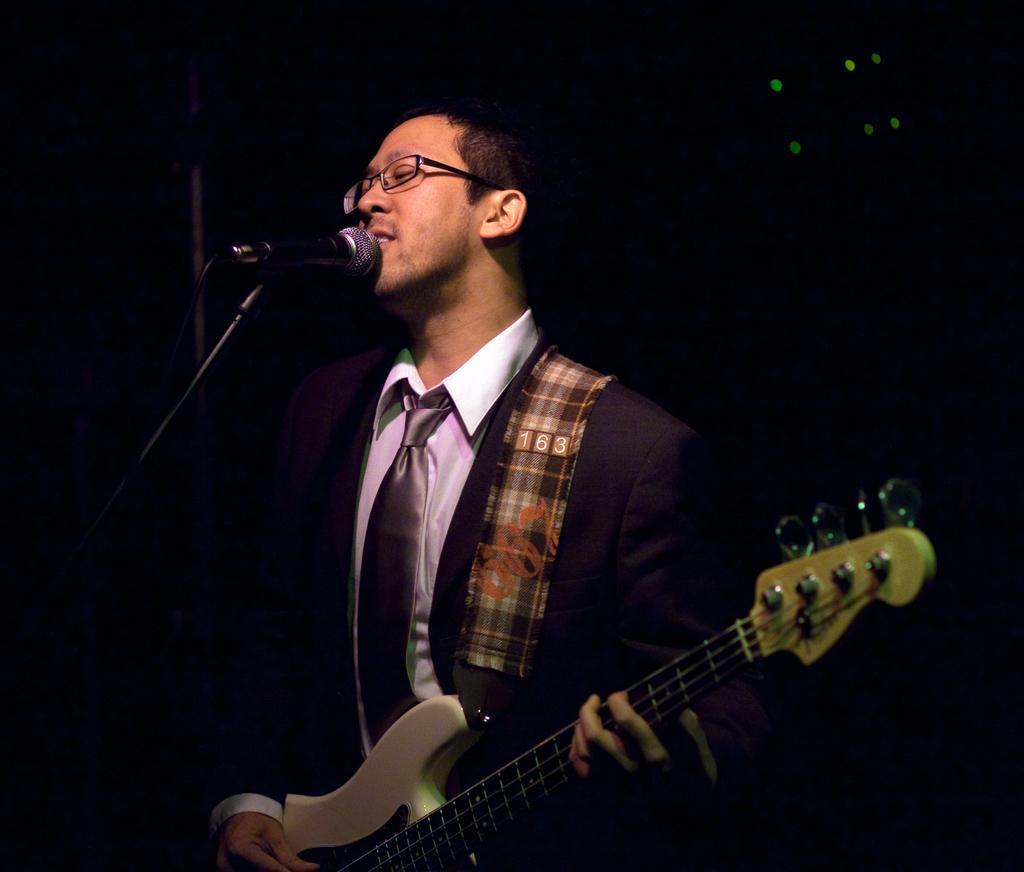How would you summarize this image in a sentence or two? This picture shows a man wearing a spectacles, playing a guitar in his hands in front of a mic and a stand. In the background there is dark. 